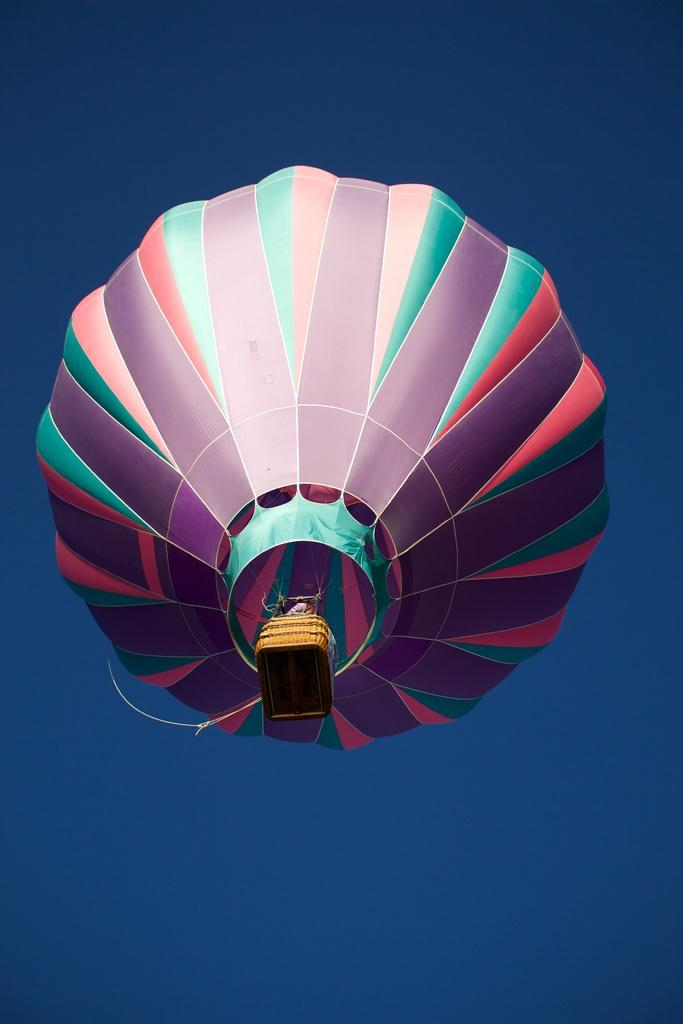What is the main subject of the image? The main subject of the image is an air balloon. Where is the air balloon located in the image? The air balloon is in the air. What can be seen in the background of the image? The sky is visible in the background of the image. Can you tell me how many boys are swimming in the lake in the image? There is no boy or lake present in the image; it features an air balloon in the air. 